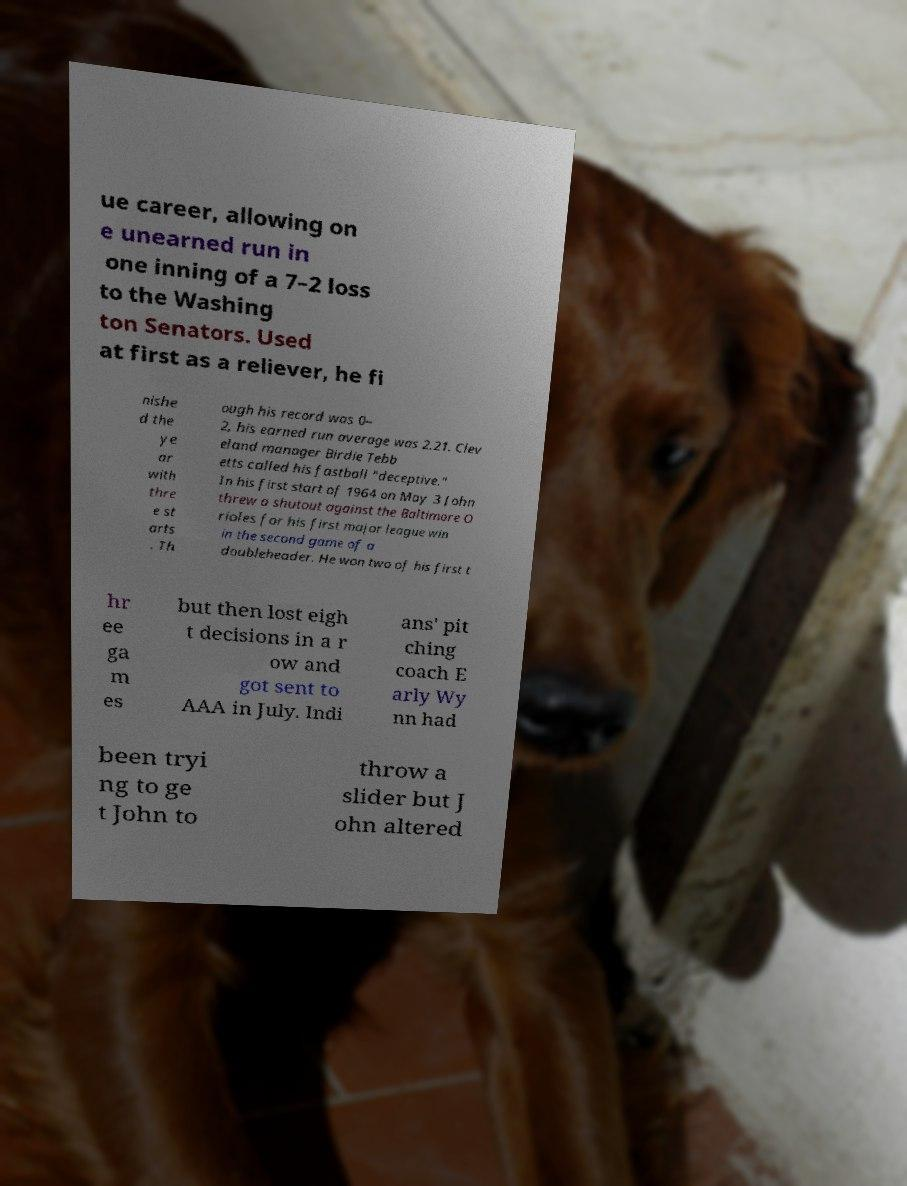Can you accurately transcribe the text from the provided image for me? ue career, allowing on e unearned run in one inning of a 7–2 loss to the Washing ton Senators. Used at first as a reliever, he fi nishe d the ye ar with thre e st arts . Th ough his record was 0– 2, his earned run average was 2.21. Clev eland manager Birdie Tebb etts called his fastball "deceptive." In his first start of 1964 on May 3 John threw a shutout against the Baltimore O rioles for his first major league win in the second game of a doubleheader. He won two of his first t hr ee ga m es but then lost eigh t decisions in a r ow and got sent to AAA in July. Indi ans' pit ching coach E arly Wy nn had been tryi ng to ge t John to throw a slider but J ohn altered 